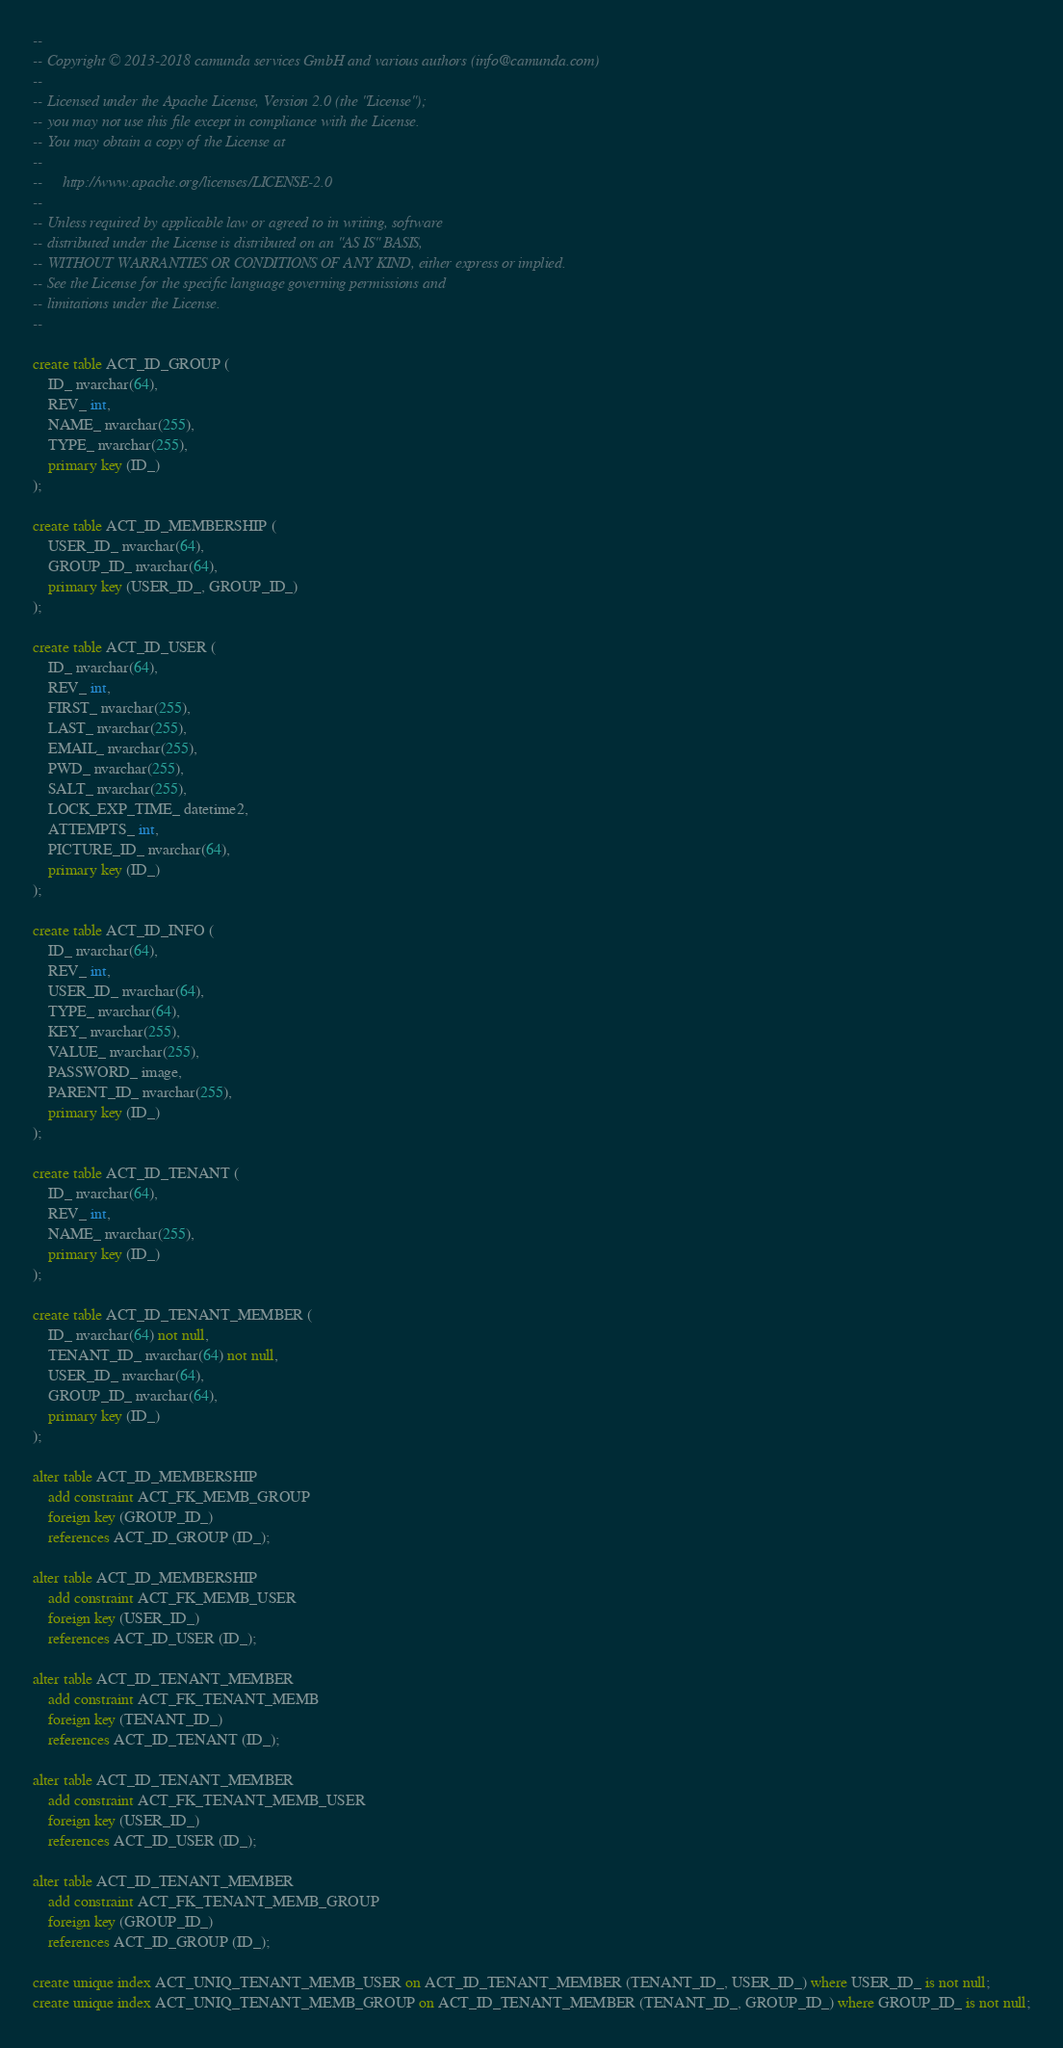<code> <loc_0><loc_0><loc_500><loc_500><_SQL_>--
-- Copyright © 2013-2018 camunda services GmbH and various authors (info@camunda.com)
--
-- Licensed under the Apache License, Version 2.0 (the "License");
-- you may not use this file except in compliance with the License.
-- You may obtain a copy of the License at
--
--     http://www.apache.org/licenses/LICENSE-2.0
--
-- Unless required by applicable law or agreed to in writing, software
-- distributed under the License is distributed on an "AS IS" BASIS,
-- WITHOUT WARRANTIES OR CONDITIONS OF ANY KIND, either express or implied.
-- See the License for the specific language governing permissions and
-- limitations under the License.
--

create table ACT_ID_GROUP (
    ID_ nvarchar(64),
    REV_ int,
    NAME_ nvarchar(255),
    TYPE_ nvarchar(255),
    primary key (ID_)
);

create table ACT_ID_MEMBERSHIP (
    USER_ID_ nvarchar(64),
    GROUP_ID_ nvarchar(64),
    primary key (USER_ID_, GROUP_ID_)
);

create table ACT_ID_USER (
    ID_ nvarchar(64),
    REV_ int,
    FIRST_ nvarchar(255),
    LAST_ nvarchar(255),
    EMAIL_ nvarchar(255),
    PWD_ nvarchar(255),
    SALT_ nvarchar(255),
    LOCK_EXP_TIME_ datetime2,
    ATTEMPTS_ int,
    PICTURE_ID_ nvarchar(64),
    primary key (ID_)
);

create table ACT_ID_INFO (
    ID_ nvarchar(64),
    REV_ int,
    USER_ID_ nvarchar(64),
    TYPE_ nvarchar(64),
    KEY_ nvarchar(255),
    VALUE_ nvarchar(255),
    PASSWORD_ image,
    PARENT_ID_ nvarchar(255),
    primary key (ID_)
);

create table ACT_ID_TENANT (
    ID_ nvarchar(64),
    REV_ int,
    NAME_ nvarchar(255),
    primary key (ID_)
);

create table ACT_ID_TENANT_MEMBER (
    ID_ nvarchar(64) not null,
    TENANT_ID_ nvarchar(64) not null,
    USER_ID_ nvarchar(64),
    GROUP_ID_ nvarchar(64),
    primary key (ID_)
);

alter table ACT_ID_MEMBERSHIP
    add constraint ACT_FK_MEMB_GROUP
    foreign key (GROUP_ID_)
    references ACT_ID_GROUP (ID_);

alter table ACT_ID_MEMBERSHIP
    add constraint ACT_FK_MEMB_USER
    foreign key (USER_ID_)
    references ACT_ID_USER (ID_);

alter table ACT_ID_TENANT_MEMBER
    add constraint ACT_FK_TENANT_MEMB
    foreign key (TENANT_ID_)
    references ACT_ID_TENANT (ID_);

alter table ACT_ID_TENANT_MEMBER
    add constraint ACT_FK_TENANT_MEMB_USER
    foreign key (USER_ID_)
    references ACT_ID_USER (ID_);

alter table ACT_ID_TENANT_MEMBER
    add constraint ACT_FK_TENANT_MEMB_GROUP
    foreign key (GROUP_ID_)
    references ACT_ID_GROUP (ID_);

create unique index ACT_UNIQ_TENANT_MEMB_USER on ACT_ID_TENANT_MEMBER (TENANT_ID_, USER_ID_) where USER_ID_ is not null;
create unique index ACT_UNIQ_TENANT_MEMB_GROUP on ACT_ID_TENANT_MEMBER (TENANT_ID_, GROUP_ID_) where GROUP_ID_ is not null;
</code> 